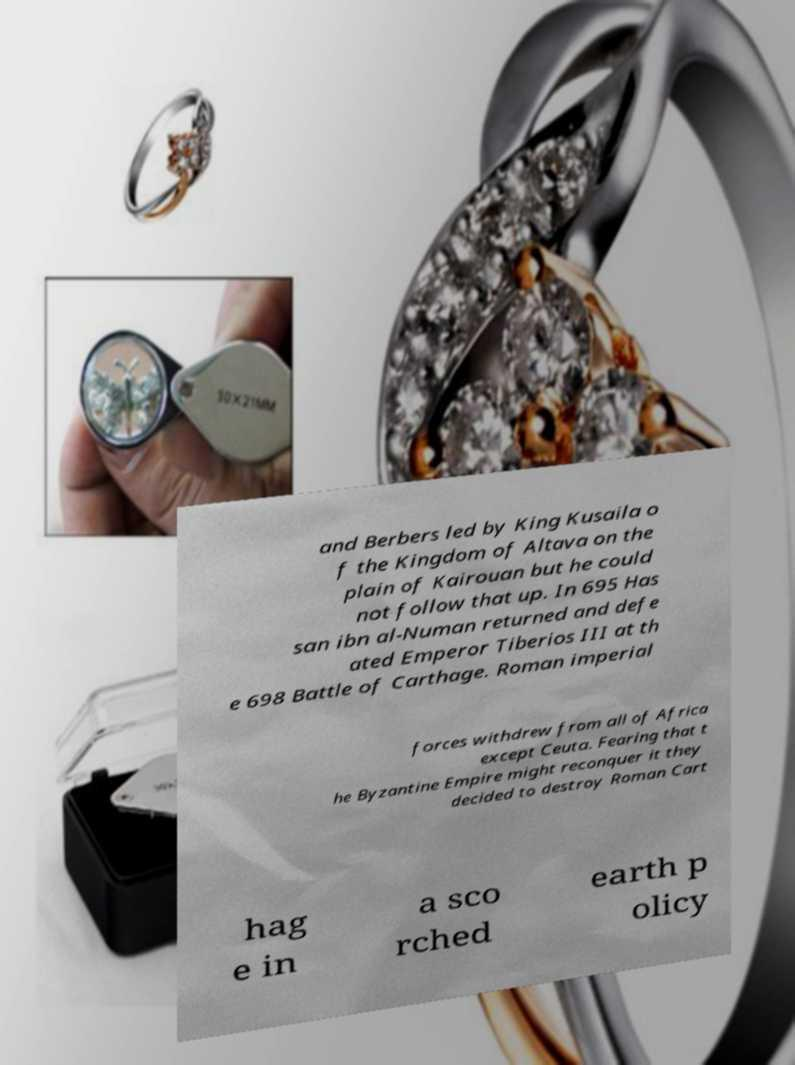Please identify and transcribe the text found in this image. and Berbers led by King Kusaila o f the Kingdom of Altava on the plain of Kairouan but he could not follow that up. In 695 Has san ibn al-Numan returned and defe ated Emperor Tiberios III at th e 698 Battle of Carthage. Roman imperial forces withdrew from all of Africa except Ceuta. Fearing that t he Byzantine Empire might reconquer it they decided to destroy Roman Cart hag e in a sco rched earth p olicy 